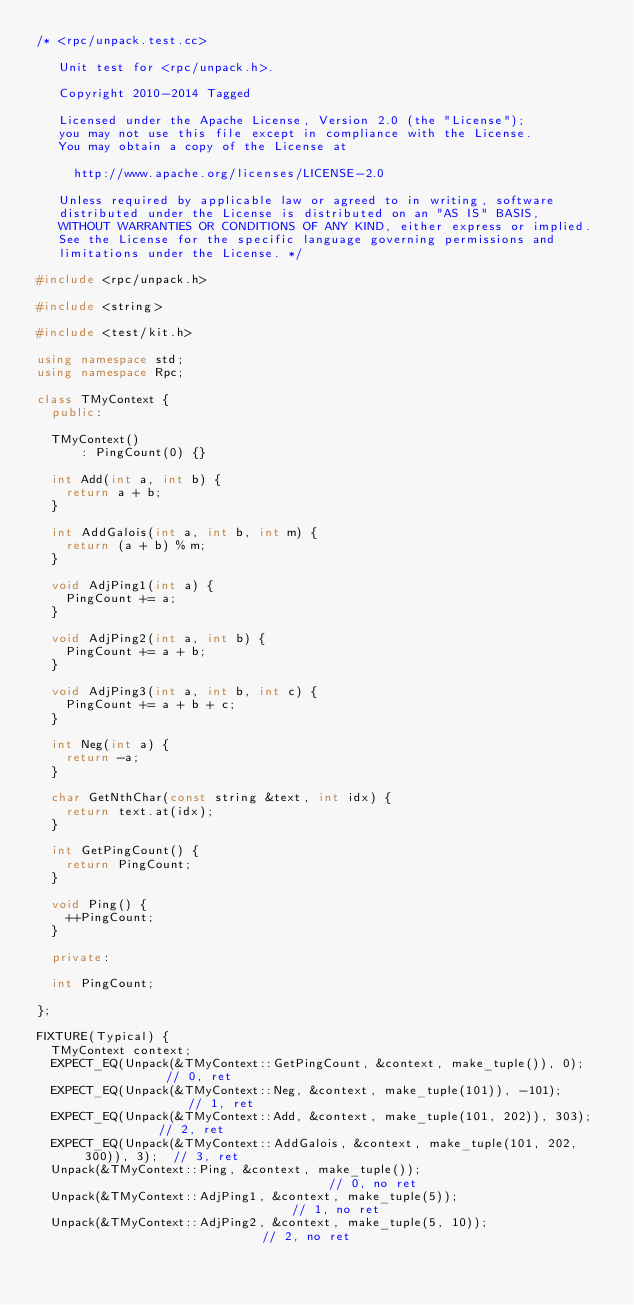<code> <loc_0><loc_0><loc_500><loc_500><_C++_>/* <rpc/unpack.test.cc> 

   Unit test for <rpc/unpack.h>.

   Copyright 2010-2014 Tagged
   
   Licensed under the Apache License, Version 2.0 (the "License");
   you may not use this file except in compliance with the License.
   You may obtain a copy of the License at
   
     http://www.apache.org/licenses/LICENSE-2.0
   
   Unless required by applicable law or agreed to in writing, software
   distributed under the License is distributed on an "AS IS" BASIS,
   WITHOUT WARRANTIES OR CONDITIONS OF ANY KIND, either express or implied.
   See the License for the specific language governing permissions and
   limitations under the License. */

#include <rpc/unpack.h>

#include <string>

#include <test/kit.h>

using namespace std;
using namespace Rpc;

class TMyContext {
  public:

  TMyContext()
      : PingCount(0) {}

  int Add(int a, int b) {
    return a + b;
  }

  int AddGalois(int a, int b, int m) {
    return (a + b) % m;
  }

  void AdjPing1(int a) {
    PingCount += a;
  }

  void AdjPing2(int a, int b) {
    PingCount += a + b;
  }

  void AdjPing3(int a, int b, int c) {
    PingCount += a + b + c;
  }

  int Neg(int a) {
    return -a;
  }

  char GetNthChar(const string &text, int idx) {
    return text.at(idx);
  }

  int GetPingCount() {
    return PingCount;
  }

  void Ping() {
    ++PingCount;
  }

  private:

  int PingCount;

};

FIXTURE(Typical) {
  TMyContext context;
  EXPECT_EQ(Unpack(&TMyContext::GetPingCount, &context, make_tuple()), 0);            // 0, ret
  EXPECT_EQ(Unpack(&TMyContext::Neg, &context, make_tuple(101)), -101);               // 1, ret
  EXPECT_EQ(Unpack(&TMyContext::Add, &context, make_tuple(101, 202)), 303);           // 2, ret
  EXPECT_EQ(Unpack(&TMyContext::AddGalois, &context, make_tuple(101, 202, 300)), 3);  // 3, ret
  Unpack(&TMyContext::Ping, &context, make_tuple());                                  // 0, no ret
  Unpack(&TMyContext::AdjPing1, &context, make_tuple(5));                             // 1, no ret
  Unpack(&TMyContext::AdjPing2, &context, make_tuple(5, 10));                         // 2, no ret</code> 